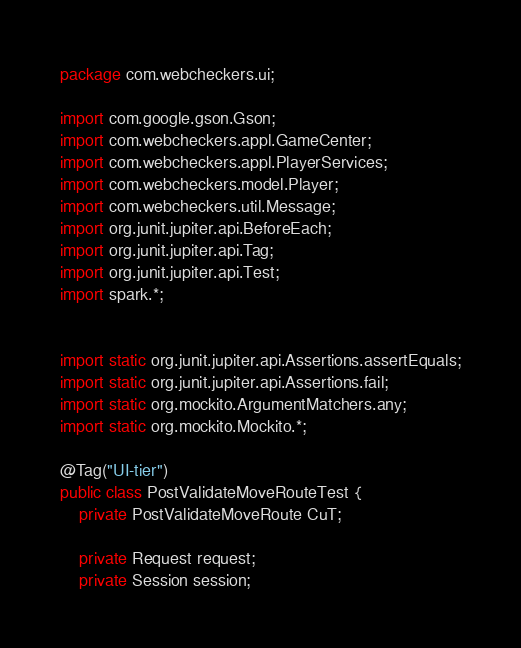<code> <loc_0><loc_0><loc_500><loc_500><_Java_>package com.webcheckers.ui;

import com.google.gson.Gson;
import com.webcheckers.appl.GameCenter;
import com.webcheckers.appl.PlayerServices;
import com.webcheckers.model.Player;
import com.webcheckers.util.Message;
import org.junit.jupiter.api.BeforeEach;
import org.junit.jupiter.api.Tag;
import org.junit.jupiter.api.Test;
import spark.*;


import static org.junit.jupiter.api.Assertions.assertEquals;
import static org.junit.jupiter.api.Assertions.fail;
import static org.mockito.ArgumentMatchers.any;
import static org.mockito.Mockito.*;

@Tag("UI-tier")
public class PostValidateMoveRouteTest {
    private PostValidateMoveRoute CuT;

    private Request request;
    private Session session;</code> 